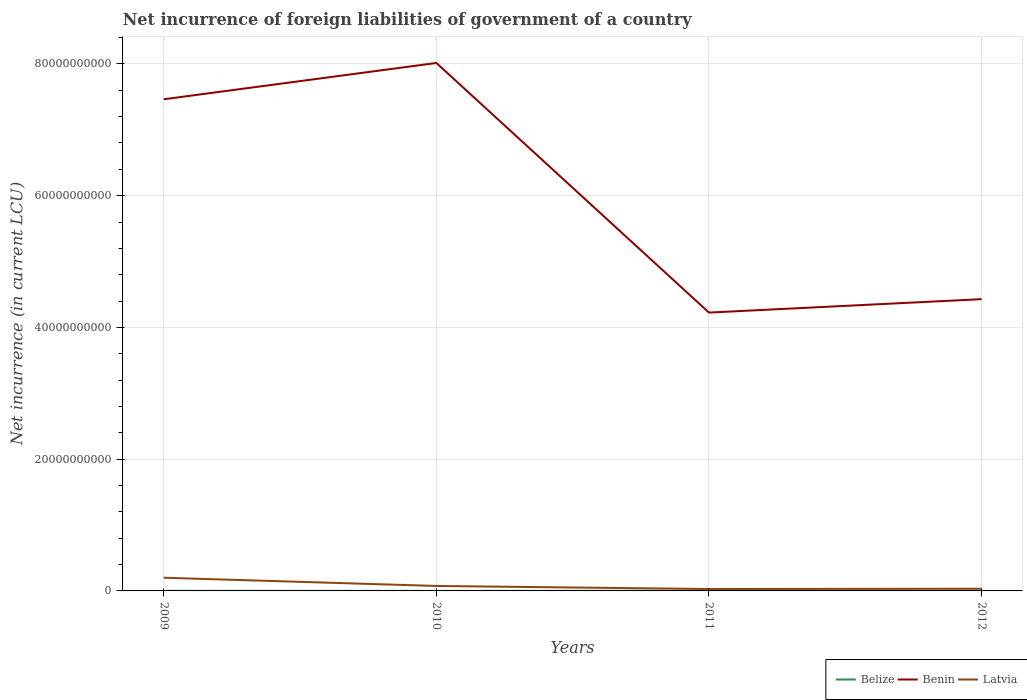How many different coloured lines are there?
Your response must be concise. 3. Across all years, what is the maximum net incurrence of foreign liabilities in Benin?
Offer a terse response. 4.23e+1. What is the total net incurrence of foreign liabilities in Benin in the graph?
Your answer should be compact. 3.79e+1. What is the difference between the highest and the second highest net incurrence of foreign liabilities in Benin?
Keep it short and to the point. 3.79e+1. What is the difference between two consecutive major ticks on the Y-axis?
Keep it short and to the point. 2.00e+1. Are the values on the major ticks of Y-axis written in scientific E-notation?
Offer a terse response. No. Where does the legend appear in the graph?
Your response must be concise. Bottom right. How are the legend labels stacked?
Your answer should be compact. Horizontal. What is the title of the graph?
Provide a succinct answer. Net incurrence of foreign liabilities of government of a country. Does "Luxembourg" appear as one of the legend labels in the graph?
Ensure brevity in your answer.  No. What is the label or title of the X-axis?
Give a very brief answer. Years. What is the label or title of the Y-axis?
Make the answer very short. Net incurrence (in current LCU). What is the Net incurrence (in current LCU) in Belize in 2009?
Keep it short and to the point. 1.56e+07. What is the Net incurrence (in current LCU) of Benin in 2009?
Offer a terse response. 7.46e+1. What is the Net incurrence (in current LCU) in Latvia in 2009?
Your answer should be compact. 2.00e+09. What is the Net incurrence (in current LCU) in Belize in 2010?
Your answer should be very brief. 2.74e+06. What is the Net incurrence (in current LCU) of Benin in 2010?
Keep it short and to the point. 8.01e+1. What is the Net incurrence (in current LCU) in Latvia in 2010?
Provide a short and direct response. 7.55e+08. What is the Net incurrence (in current LCU) of Belize in 2011?
Make the answer very short. 2.52e+07. What is the Net incurrence (in current LCU) of Benin in 2011?
Provide a succinct answer. 4.23e+1. What is the Net incurrence (in current LCU) of Latvia in 2011?
Your answer should be very brief. 2.88e+08. What is the Net incurrence (in current LCU) in Belize in 2012?
Your response must be concise. 4.13e+07. What is the Net incurrence (in current LCU) of Benin in 2012?
Provide a short and direct response. 4.43e+1. What is the Net incurrence (in current LCU) of Latvia in 2012?
Provide a short and direct response. 3.33e+08. Across all years, what is the maximum Net incurrence (in current LCU) of Belize?
Offer a terse response. 4.13e+07. Across all years, what is the maximum Net incurrence (in current LCU) in Benin?
Ensure brevity in your answer.  8.01e+1. Across all years, what is the maximum Net incurrence (in current LCU) in Latvia?
Keep it short and to the point. 2.00e+09. Across all years, what is the minimum Net incurrence (in current LCU) in Belize?
Give a very brief answer. 2.74e+06. Across all years, what is the minimum Net incurrence (in current LCU) in Benin?
Give a very brief answer. 4.23e+1. Across all years, what is the minimum Net incurrence (in current LCU) in Latvia?
Ensure brevity in your answer.  2.88e+08. What is the total Net incurrence (in current LCU) of Belize in the graph?
Provide a succinct answer. 8.49e+07. What is the total Net incurrence (in current LCU) in Benin in the graph?
Ensure brevity in your answer.  2.41e+11. What is the total Net incurrence (in current LCU) of Latvia in the graph?
Give a very brief answer. 3.38e+09. What is the difference between the Net incurrence (in current LCU) in Belize in 2009 and that in 2010?
Provide a succinct answer. 1.29e+07. What is the difference between the Net incurrence (in current LCU) of Benin in 2009 and that in 2010?
Your response must be concise. -5.51e+09. What is the difference between the Net incurrence (in current LCU) in Latvia in 2009 and that in 2010?
Offer a very short reply. 1.25e+09. What is the difference between the Net incurrence (in current LCU) in Belize in 2009 and that in 2011?
Give a very brief answer. -9.60e+06. What is the difference between the Net incurrence (in current LCU) in Benin in 2009 and that in 2011?
Make the answer very short. 3.24e+1. What is the difference between the Net incurrence (in current LCU) in Latvia in 2009 and that in 2011?
Provide a succinct answer. 1.71e+09. What is the difference between the Net incurrence (in current LCU) of Belize in 2009 and that in 2012?
Your answer should be compact. -2.57e+07. What is the difference between the Net incurrence (in current LCU) of Benin in 2009 and that in 2012?
Make the answer very short. 3.03e+1. What is the difference between the Net incurrence (in current LCU) in Latvia in 2009 and that in 2012?
Give a very brief answer. 1.67e+09. What is the difference between the Net incurrence (in current LCU) in Belize in 2010 and that in 2011?
Your answer should be compact. -2.25e+07. What is the difference between the Net incurrence (in current LCU) in Benin in 2010 and that in 2011?
Your answer should be very brief. 3.79e+1. What is the difference between the Net incurrence (in current LCU) in Latvia in 2010 and that in 2011?
Keep it short and to the point. 4.66e+08. What is the difference between the Net incurrence (in current LCU) in Belize in 2010 and that in 2012?
Offer a very short reply. -3.86e+07. What is the difference between the Net incurrence (in current LCU) of Benin in 2010 and that in 2012?
Offer a very short reply. 3.59e+1. What is the difference between the Net incurrence (in current LCU) of Latvia in 2010 and that in 2012?
Keep it short and to the point. 4.22e+08. What is the difference between the Net incurrence (in current LCU) in Belize in 2011 and that in 2012?
Your answer should be compact. -1.61e+07. What is the difference between the Net incurrence (in current LCU) of Benin in 2011 and that in 2012?
Give a very brief answer. -2.04e+09. What is the difference between the Net incurrence (in current LCU) of Latvia in 2011 and that in 2012?
Provide a short and direct response. -4.42e+07. What is the difference between the Net incurrence (in current LCU) in Belize in 2009 and the Net incurrence (in current LCU) in Benin in 2010?
Your response must be concise. -8.01e+1. What is the difference between the Net incurrence (in current LCU) of Belize in 2009 and the Net incurrence (in current LCU) of Latvia in 2010?
Offer a terse response. -7.39e+08. What is the difference between the Net incurrence (in current LCU) of Benin in 2009 and the Net incurrence (in current LCU) of Latvia in 2010?
Give a very brief answer. 7.39e+1. What is the difference between the Net incurrence (in current LCU) of Belize in 2009 and the Net incurrence (in current LCU) of Benin in 2011?
Make the answer very short. -4.22e+1. What is the difference between the Net incurrence (in current LCU) of Belize in 2009 and the Net incurrence (in current LCU) of Latvia in 2011?
Offer a terse response. -2.73e+08. What is the difference between the Net incurrence (in current LCU) in Benin in 2009 and the Net incurrence (in current LCU) in Latvia in 2011?
Keep it short and to the point. 7.43e+1. What is the difference between the Net incurrence (in current LCU) in Belize in 2009 and the Net incurrence (in current LCU) in Benin in 2012?
Make the answer very short. -4.43e+1. What is the difference between the Net incurrence (in current LCU) of Belize in 2009 and the Net incurrence (in current LCU) of Latvia in 2012?
Your answer should be compact. -3.17e+08. What is the difference between the Net incurrence (in current LCU) in Benin in 2009 and the Net incurrence (in current LCU) in Latvia in 2012?
Keep it short and to the point. 7.43e+1. What is the difference between the Net incurrence (in current LCU) of Belize in 2010 and the Net incurrence (in current LCU) of Benin in 2011?
Ensure brevity in your answer.  -4.22e+1. What is the difference between the Net incurrence (in current LCU) of Belize in 2010 and the Net incurrence (in current LCU) of Latvia in 2011?
Your answer should be very brief. -2.86e+08. What is the difference between the Net incurrence (in current LCU) of Benin in 2010 and the Net incurrence (in current LCU) of Latvia in 2011?
Keep it short and to the point. 7.99e+1. What is the difference between the Net incurrence (in current LCU) in Belize in 2010 and the Net incurrence (in current LCU) in Benin in 2012?
Your answer should be compact. -4.43e+1. What is the difference between the Net incurrence (in current LCU) of Belize in 2010 and the Net incurrence (in current LCU) of Latvia in 2012?
Offer a terse response. -3.30e+08. What is the difference between the Net incurrence (in current LCU) of Benin in 2010 and the Net incurrence (in current LCU) of Latvia in 2012?
Offer a terse response. 7.98e+1. What is the difference between the Net incurrence (in current LCU) of Belize in 2011 and the Net incurrence (in current LCU) of Benin in 2012?
Provide a succinct answer. -4.43e+1. What is the difference between the Net incurrence (in current LCU) of Belize in 2011 and the Net incurrence (in current LCU) of Latvia in 2012?
Your answer should be very brief. -3.07e+08. What is the difference between the Net incurrence (in current LCU) in Benin in 2011 and the Net incurrence (in current LCU) in Latvia in 2012?
Ensure brevity in your answer.  4.19e+1. What is the average Net incurrence (in current LCU) in Belize per year?
Give a very brief answer. 2.12e+07. What is the average Net incurrence (in current LCU) in Benin per year?
Offer a terse response. 6.03e+1. What is the average Net incurrence (in current LCU) in Latvia per year?
Provide a short and direct response. 8.44e+08. In the year 2009, what is the difference between the Net incurrence (in current LCU) in Belize and Net incurrence (in current LCU) in Benin?
Offer a very short reply. -7.46e+1. In the year 2009, what is the difference between the Net incurrence (in current LCU) in Belize and Net incurrence (in current LCU) in Latvia?
Ensure brevity in your answer.  -1.99e+09. In the year 2009, what is the difference between the Net incurrence (in current LCU) of Benin and Net incurrence (in current LCU) of Latvia?
Keep it short and to the point. 7.26e+1. In the year 2010, what is the difference between the Net incurrence (in current LCU) of Belize and Net incurrence (in current LCU) of Benin?
Offer a terse response. -8.01e+1. In the year 2010, what is the difference between the Net incurrence (in current LCU) in Belize and Net incurrence (in current LCU) in Latvia?
Keep it short and to the point. -7.52e+08. In the year 2010, what is the difference between the Net incurrence (in current LCU) in Benin and Net incurrence (in current LCU) in Latvia?
Offer a very short reply. 7.94e+1. In the year 2011, what is the difference between the Net incurrence (in current LCU) in Belize and Net incurrence (in current LCU) in Benin?
Offer a very short reply. -4.22e+1. In the year 2011, what is the difference between the Net incurrence (in current LCU) of Belize and Net incurrence (in current LCU) of Latvia?
Your response must be concise. -2.63e+08. In the year 2011, what is the difference between the Net incurrence (in current LCU) in Benin and Net incurrence (in current LCU) in Latvia?
Keep it short and to the point. 4.20e+1. In the year 2012, what is the difference between the Net incurrence (in current LCU) of Belize and Net incurrence (in current LCU) of Benin?
Offer a very short reply. -4.42e+1. In the year 2012, what is the difference between the Net incurrence (in current LCU) of Belize and Net incurrence (in current LCU) of Latvia?
Provide a short and direct response. -2.91e+08. In the year 2012, what is the difference between the Net incurrence (in current LCU) of Benin and Net incurrence (in current LCU) of Latvia?
Keep it short and to the point. 4.40e+1. What is the ratio of the Net incurrence (in current LCU) in Belize in 2009 to that in 2010?
Offer a terse response. 5.71. What is the ratio of the Net incurrence (in current LCU) in Benin in 2009 to that in 2010?
Ensure brevity in your answer.  0.93. What is the ratio of the Net incurrence (in current LCU) in Latvia in 2009 to that in 2010?
Offer a very short reply. 2.65. What is the ratio of the Net incurrence (in current LCU) in Belize in 2009 to that in 2011?
Your answer should be compact. 0.62. What is the ratio of the Net incurrence (in current LCU) in Benin in 2009 to that in 2011?
Provide a succinct answer. 1.77. What is the ratio of the Net incurrence (in current LCU) of Latvia in 2009 to that in 2011?
Give a very brief answer. 6.94. What is the ratio of the Net incurrence (in current LCU) in Belize in 2009 to that in 2012?
Give a very brief answer. 0.38. What is the ratio of the Net incurrence (in current LCU) in Benin in 2009 to that in 2012?
Offer a terse response. 1.69. What is the ratio of the Net incurrence (in current LCU) of Latvia in 2009 to that in 2012?
Ensure brevity in your answer.  6.02. What is the ratio of the Net incurrence (in current LCU) in Belize in 2010 to that in 2011?
Ensure brevity in your answer.  0.11. What is the ratio of the Net incurrence (in current LCU) in Benin in 2010 to that in 2011?
Provide a short and direct response. 1.9. What is the ratio of the Net incurrence (in current LCU) in Latvia in 2010 to that in 2011?
Make the answer very short. 2.62. What is the ratio of the Net incurrence (in current LCU) in Belize in 2010 to that in 2012?
Your answer should be very brief. 0.07. What is the ratio of the Net incurrence (in current LCU) in Benin in 2010 to that in 2012?
Ensure brevity in your answer.  1.81. What is the ratio of the Net incurrence (in current LCU) of Latvia in 2010 to that in 2012?
Your answer should be compact. 2.27. What is the ratio of the Net incurrence (in current LCU) in Belize in 2011 to that in 2012?
Give a very brief answer. 0.61. What is the ratio of the Net incurrence (in current LCU) in Benin in 2011 to that in 2012?
Provide a short and direct response. 0.95. What is the ratio of the Net incurrence (in current LCU) of Latvia in 2011 to that in 2012?
Keep it short and to the point. 0.87. What is the difference between the highest and the second highest Net incurrence (in current LCU) in Belize?
Make the answer very short. 1.61e+07. What is the difference between the highest and the second highest Net incurrence (in current LCU) of Benin?
Your response must be concise. 5.51e+09. What is the difference between the highest and the second highest Net incurrence (in current LCU) in Latvia?
Give a very brief answer. 1.25e+09. What is the difference between the highest and the lowest Net incurrence (in current LCU) in Belize?
Ensure brevity in your answer.  3.86e+07. What is the difference between the highest and the lowest Net incurrence (in current LCU) of Benin?
Provide a short and direct response. 3.79e+1. What is the difference between the highest and the lowest Net incurrence (in current LCU) of Latvia?
Make the answer very short. 1.71e+09. 